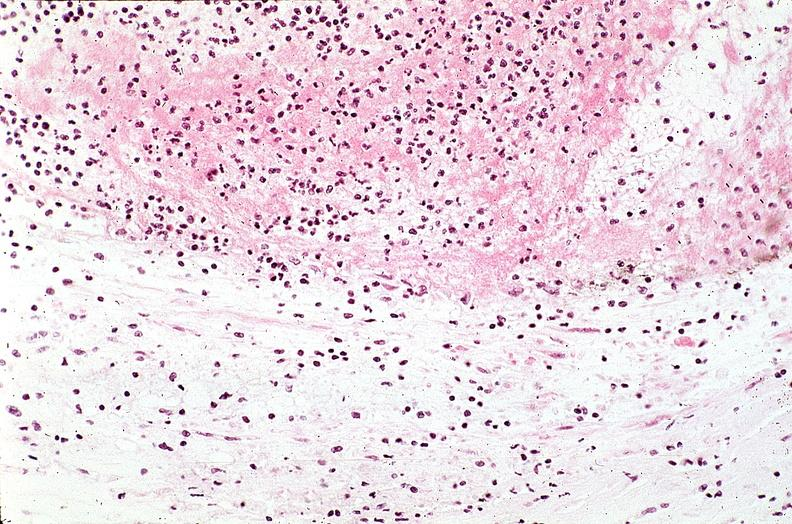s muscle atrophy present?
Answer the question using a single word or phrase. No 